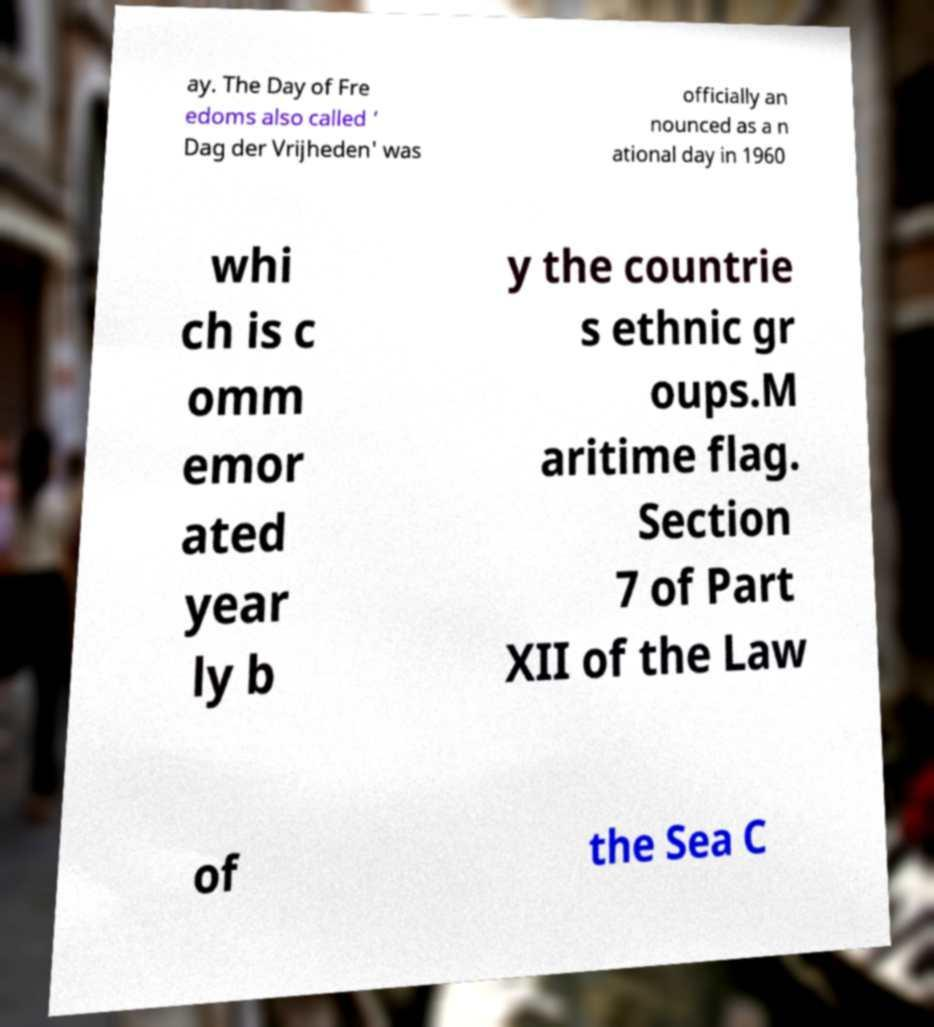Can you read and provide the text displayed in the image?This photo seems to have some interesting text. Can you extract and type it out for me? ay. The Day of Fre edoms also called ‘ Dag der Vrijheden' was officially an nounced as a n ational day in 1960 whi ch is c omm emor ated year ly b y the countrie s ethnic gr oups.M aritime flag. Section 7 of Part XII of the Law of the Sea C 